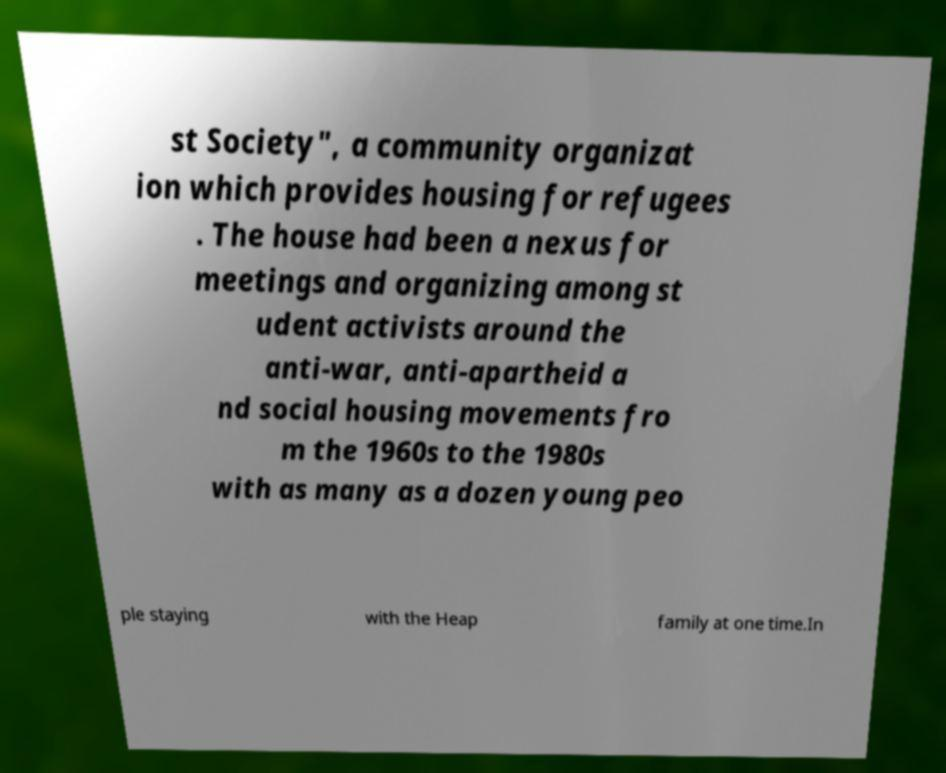Please read and relay the text visible in this image. What does it say? st Society", a community organizat ion which provides housing for refugees . The house had been a nexus for meetings and organizing among st udent activists around the anti-war, anti-apartheid a nd social housing movements fro m the 1960s to the 1980s with as many as a dozen young peo ple staying with the Heap family at one time.In 